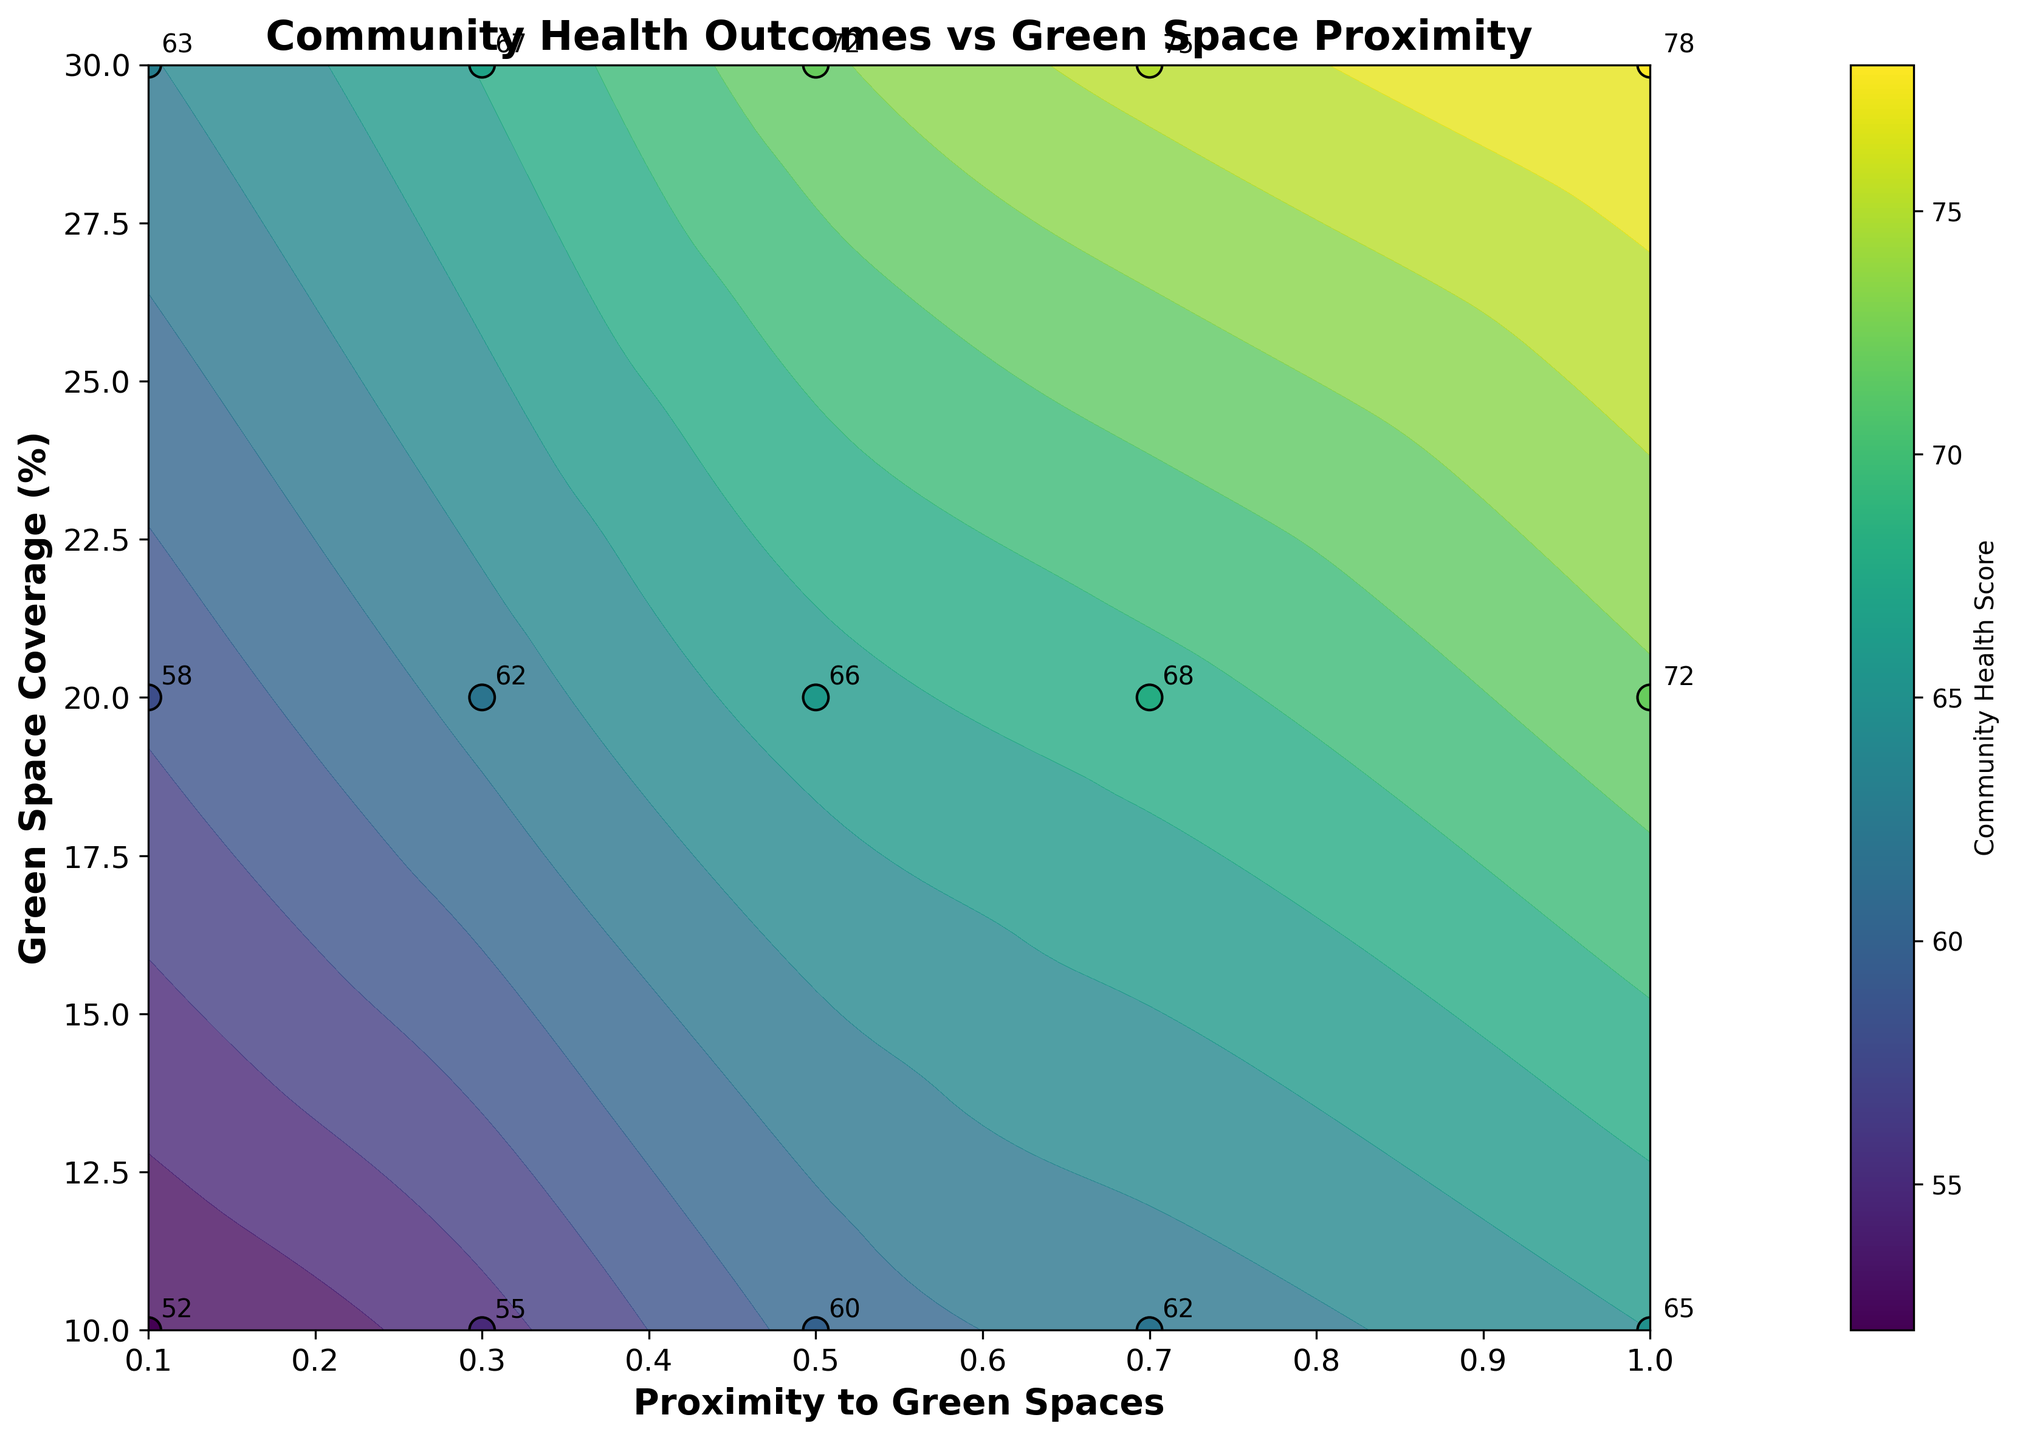What is the title of the figure? The title is usually at the top of the plot and summarizes the main theme of the figure.
Answer: Community Health Outcomes vs Green Space Proximity What are the labels of the x-axis and y-axis? The labels of the axes can be found directly below the x-axis and to the left of the y-axis respectively.
Answer: Proximity to Green Spaces and Green Space Coverage (%) How many contour levels are there in the plot? Contour levels are the distinct lines or color bands represented in the plot. Count them to get the answer.
Answer: 15 Which data point has the highest Community Health Score and what is the corresponding Proximity and Green Space Coverage (%)? Look for the highest labeled score on the plot and note its x and y coordinates.
Answer: The highest score is 78, with a Proximity of 1.0 and Green Space Coverage of 30% How does Community Health Score generally change with increasing Green Space Coverage (%) at a fixed proximity? Observe the contour lines and labeled points vertically along a fixed x-value to see the trend.
Answer: It generally increases What's the difference in Community Health Score between the closest (Proximity = 0.1) and farthest (Proximity = 1.0) points when Green Space Coverage is 20%? Identify the scores for Proximity 0.1 and 1.0 at 20% Green Space Coverage and calculate the difference.
Answer: 72 - 58 = 14 Is there any Proximity value where the Community Health Score consistently decreases as Green Space Coverage (%) increases? Examine the trend for each Proximity value; see if any of them show a decreasing trend in score with increasing Green Space Coverage.
Answer: No, the scores do not consistently decrease for any Proximity value What is the average Community Health Score for all points where Green Space Coverage (%) is 30%? Identify the scores for all Proximity values where Green Space Coverage is 30%, sum them up, and divide by the number of points.
Answer: (63 + 67 + 72 + 75 + 78) / 5 = 71 Which data point annotated with a label is closest to the origin (0,0)? Identify the point with the smallest x and y values while looking at the annotated labels.
Answer: The point with score 52, Proximity 0.1, and Green Space Coverage 10% Does increasing Proximity to Green Spaces generally correlate with an increase in Community Health Score irrespective of Green Space Coverage (%)? Look at how the Community Health Scores change as Proximity increases for different Green Space Coverage percentages.
Answer: Yes, generally 